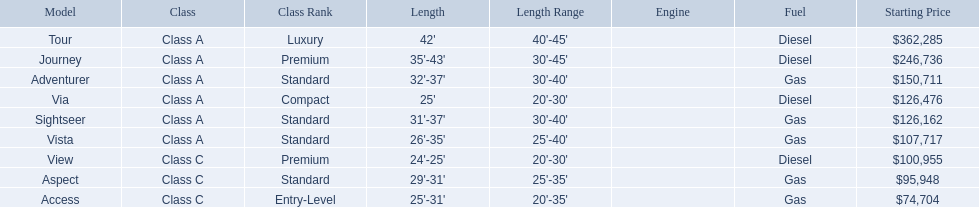Which model has the lowest starting price? Access. Which model has the second most highest starting price? Journey. Which model has the highest price in the winnebago industry? Tour. 